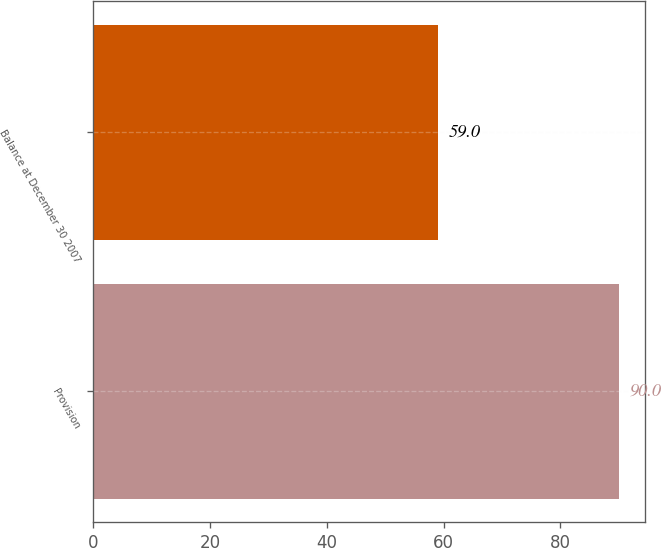<chart> <loc_0><loc_0><loc_500><loc_500><bar_chart><fcel>Provision<fcel>Balance at December 30 2007<nl><fcel>90<fcel>59<nl></chart> 